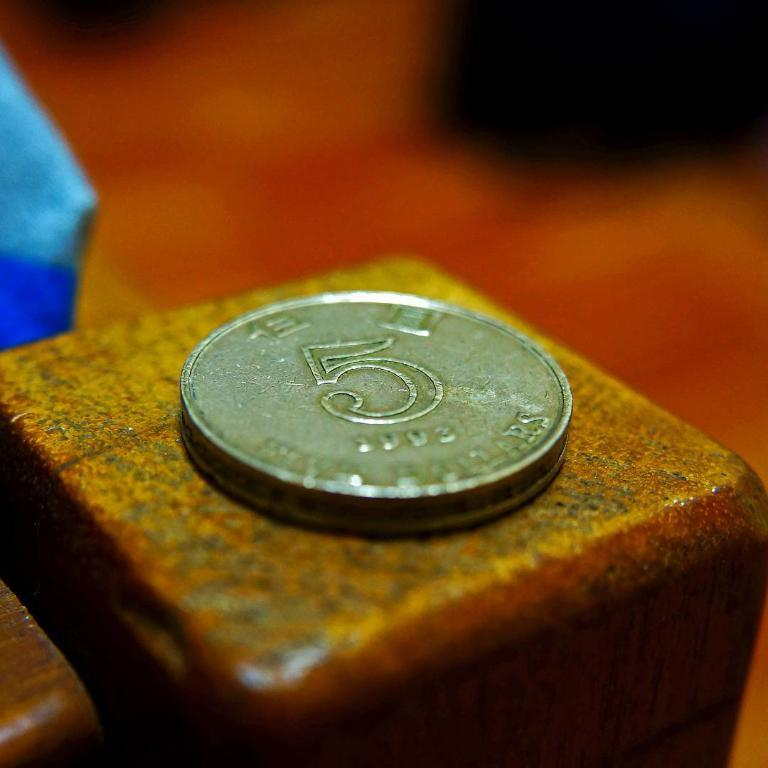<image>
Write a terse but informative summary of the picture. A gold colored coin with the number 5 sits atop a small yellow block. 